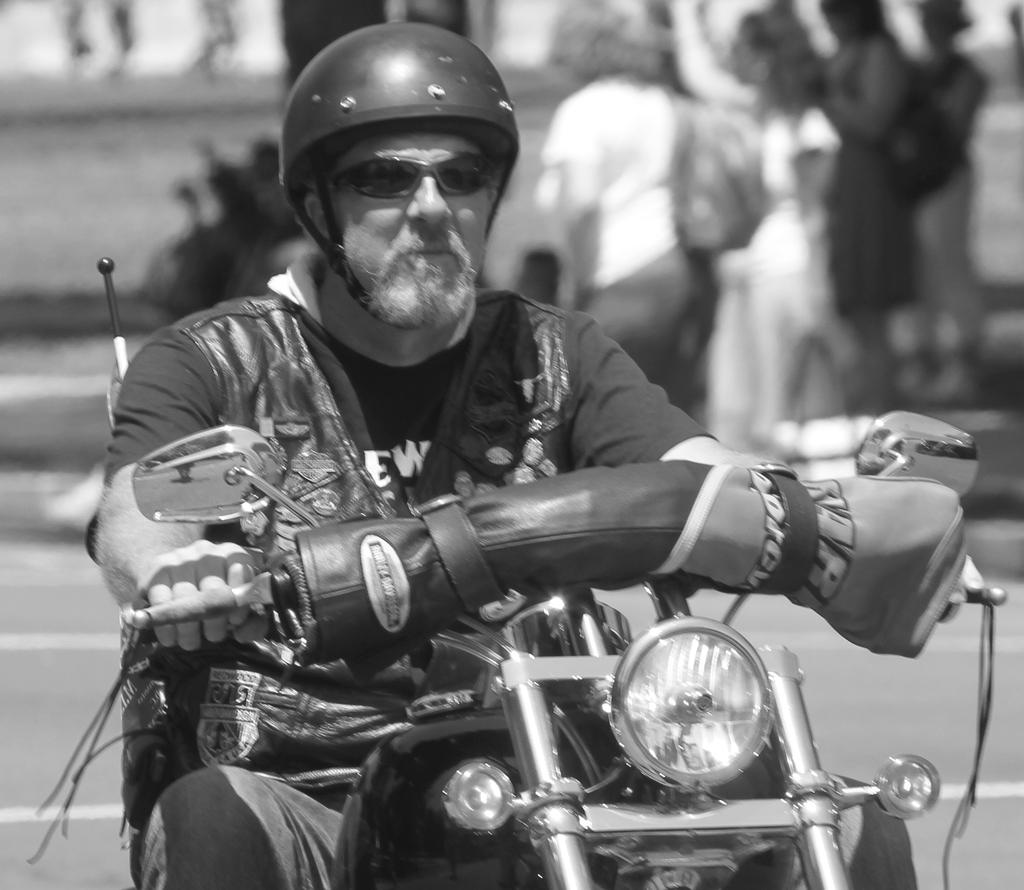What is the man in the image doing? The man is riding a bike in the image. What safety precaution is the man taking while riding the bike? The man is wearing a helmet while riding the bike. What type of eyewear is the man wearing? The man is wearing spectacles. What color is the man's t-shirt? The man's t-shirt is black in color. What type of hen can be seen in the image? A: There is no hen present in the image. 